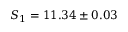Convert formula to latex. <formula><loc_0><loc_0><loc_500><loc_500>S _ { 1 } = 1 1 . 3 4 \pm 0 . 0 3</formula> 